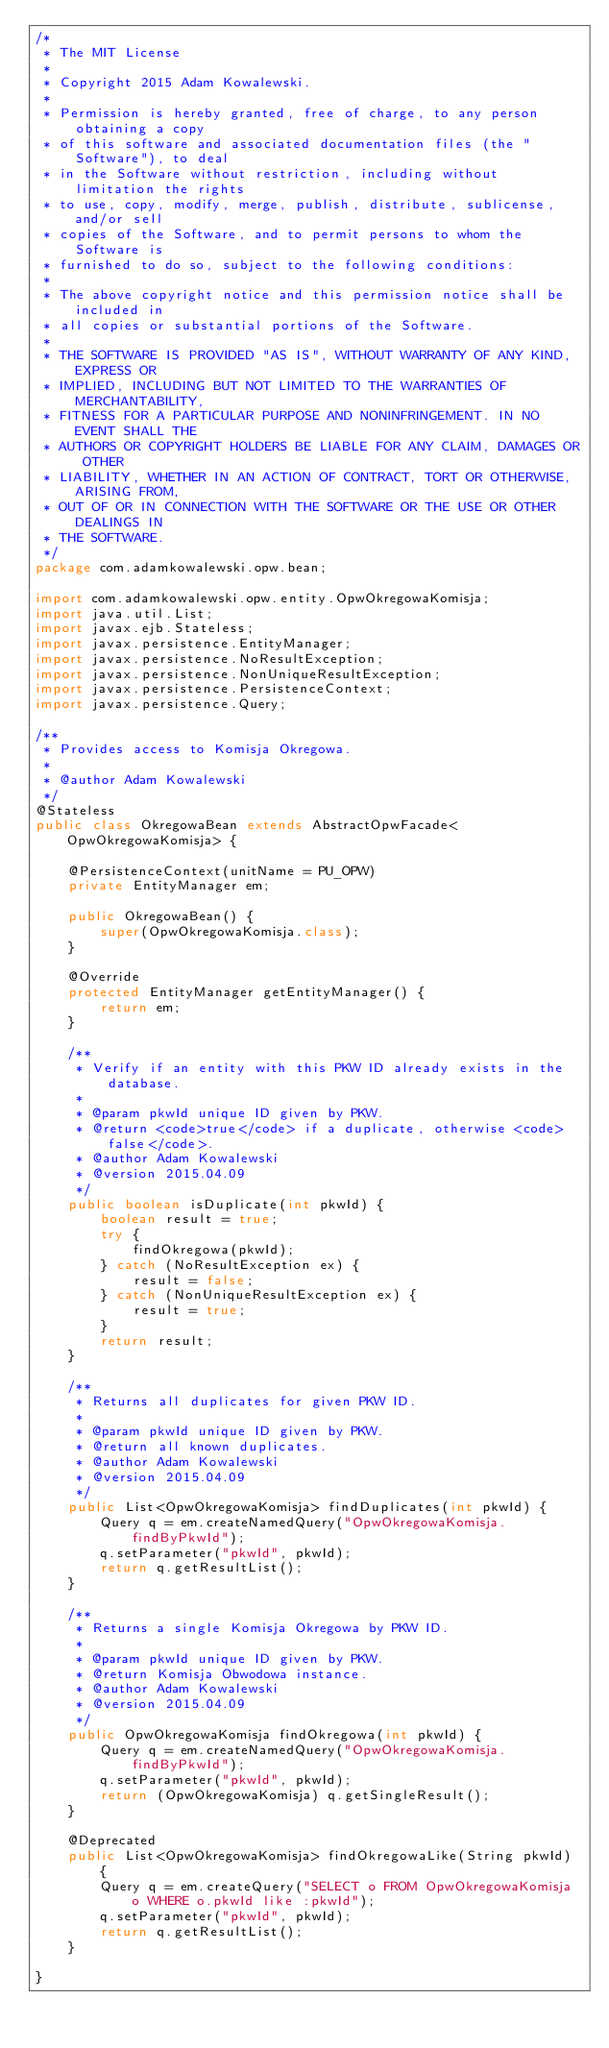<code> <loc_0><loc_0><loc_500><loc_500><_Java_>/*
 * The MIT License
 *
 * Copyright 2015 Adam Kowalewski.
 *
 * Permission is hereby granted, free of charge, to any person obtaining a copy
 * of this software and associated documentation files (the "Software"), to deal
 * in the Software without restriction, including without limitation the rights
 * to use, copy, modify, merge, publish, distribute, sublicense, and/or sell
 * copies of the Software, and to permit persons to whom the Software is
 * furnished to do so, subject to the following conditions:
 *
 * The above copyright notice and this permission notice shall be included in
 * all copies or substantial portions of the Software.
 *
 * THE SOFTWARE IS PROVIDED "AS IS", WITHOUT WARRANTY OF ANY KIND, EXPRESS OR
 * IMPLIED, INCLUDING BUT NOT LIMITED TO THE WARRANTIES OF MERCHANTABILITY,
 * FITNESS FOR A PARTICULAR PURPOSE AND NONINFRINGEMENT. IN NO EVENT SHALL THE
 * AUTHORS OR COPYRIGHT HOLDERS BE LIABLE FOR ANY CLAIM, DAMAGES OR OTHER
 * LIABILITY, WHETHER IN AN ACTION OF CONTRACT, TORT OR OTHERWISE, ARISING FROM,
 * OUT OF OR IN CONNECTION WITH THE SOFTWARE OR THE USE OR OTHER DEALINGS IN
 * THE SOFTWARE.
 */
package com.adamkowalewski.opw.bean;

import com.adamkowalewski.opw.entity.OpwOkregowaKomisja;
import java.util.List;
import javax.ejb.Stateless;
import javax.persistence.EntityManager;
import javax.persistence.NoResultException;
import javax.persistence.NonUniqueResultException;
import javax.persistence.PersistenceContext;
import javax.persistence.Query;

/**
 * Provides access to Komisja Okregowa.
 *
 * @author Adam Kowalewski
 */
@Stateless
public class OkregowaBean extends AbstractOpwFacade<OpwOkregowaKomisja> {

    @PersistenceContext(unitName = PU_OPW)
    private EntityManager em;

    public OkregowaBean() {
        super(OpwOkregowaKomisja.class);
    }

    @Override
    protected EntityManager getEntityManager() {
        return em;
    }

    /**
     * Verify if an entity with this PKW ID already exists in the database.
     *
     * @param pkwId unique ID given by PKW.
     * @return <code>true</code> if a duplicate, otherwise <code>false</code>.
     * @author Adam Kowalewski
     * @version 2015.04.09
     */
    public boolean isDuplicate(int pkwId) {
        boolean result = true;
        try {
            findOkregowa(pkwId);
        } catch (NoResultException ex) {
            result = false;
        } catch (NonUniqueResultException ex) {
            result = true;
        }
        return result;
    }

    /**
     * Returns all duplicates for given PKW ID.
     *
     * @param pkwId unique ID given by PKW.
     * @return all known duplicates.
     * @author Adam Kowalewski
     * @version 2015.04.09
     */
    public List<OpwOkregowaKomisja> findDuplicates(int pkwId) {
        Query q = em.createNamedQuery("OpwOkregowaKomisja.findByPkwId");
        q.setParameter("pkwId", pkwId);
        return q.getResultList();
    }

    /**
     * Returns a single Komisja Okregowa by PKW ID.
     *
     * @param pkwId unique ID given by PKW.
     * @return Komisja Obwodowa instance.
     * @author Adam Kowalewski
     * @version 2015.04.09
     */
    public OpwOkregowaKomisja findOkregowa(int pkwId) {
        Query q = em.createNamedQuery("OpwOkregowaKomisja.findByPkwId");
        q.setParameter("pkwId", pkwId);
        return (OpwOkregowaKomisja) q.getSingleResult();
    }

    @Deprecated
    public List<OpwOkregowaKomisja> findOkregowaLike(String pkwId) {
        Query q = em.createQuery("SELECT o FROM OpwOkregowaKomisja o WHERE o.pkwId like :pkwId");
        q.setParameter("pkwId", pkwId);
        return q.getResultList();
    }

}
</code> 